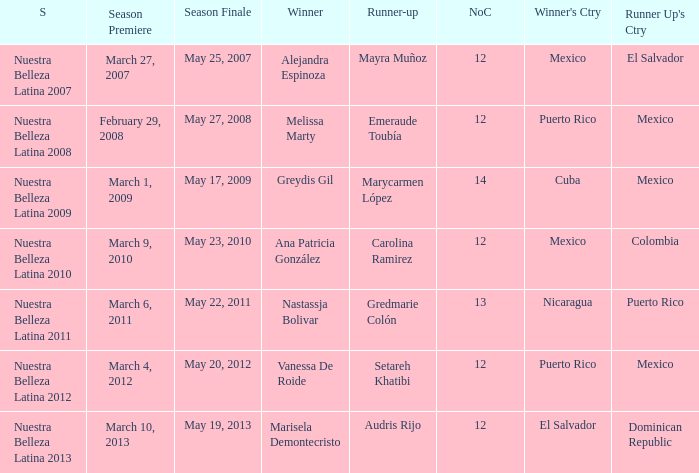Would you be able to parse every entry in this table? {'header': ['S', 'Season Premiere', 'Season Finale', 'Winner', 'Runner-up', 'NoC', "Winner's Ctry", "Runner Up's Ctry"], 'rows': [['Nuestra Belleza Latina 2007', 'March 27, 2007', 'May 25, 2007', 'Alejandra Espinoza', 'Mayra Muñoz', '12', 'Mexico', 'El Salvador'], ['Nuestra Belleza Latina 2008', 'February 29, 2008', 'May 27, 2008', 'Melissa Marty', 'Emeraude Toubía', '12', 'Puerto Rico', 'Mexico'], ['Nuestra Belleza Latina 2009', 'March 1, 2009', 'May 17, 2009', 'Greydis Gil', 'Marycarmen López', '14', 'Cuba', 'Mexico'], ['Nuestra Belleza Latina 2010', 'March 9, 2010', 'May 23, 2010', 'Ana Patricia González', 'Carolina Ramirez', '12', 'Mexico', 'Colombia'], ['Nuestra Belleza Latina 2011', 'March 6, 2011', 'May 22, 2011', 'Nastassja Bolivar', 'Gredmarie Colón', '13', 'Nicaragua', 'Puerto Rico'], ['Nuestra Belleza Latina 2012', 'March 4, 2012', 'May 20, 2012', 'Vanessa De Roide', 'Setareh Khatibi', '12', 'Puerto Rico', 'Mexico'], ['Nuestra Belleza Latina 2013', 'March 10, 2013', 'May 19, 2013', 'Marisela Demontecristo', 'Audris Rijo', '12', 'El Salvador', 'Dominican Republic']]} What season had more than 12 contestants in which greydis gil won? Nuestra Belleza Latina 2009. 